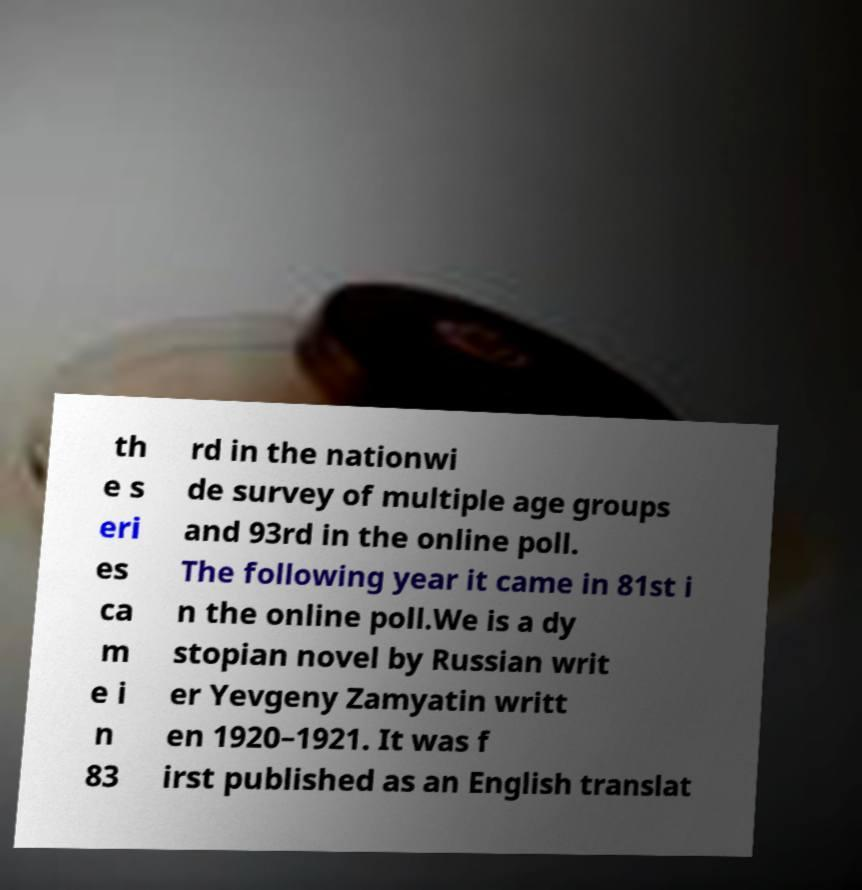There's text embedded in this image that I need extracted. Can you transcribe it verbatim? th e s eri es ca m e i n 83 rd in the nationwi de survey of multiple age groups and 93rd in the online poll. The following year it came in 81st i n the online poll.We is a dy stopian novel by Russian writ er Yevgeny Zamyatin writt en 1920–1921. It was f irst published as an English translat 